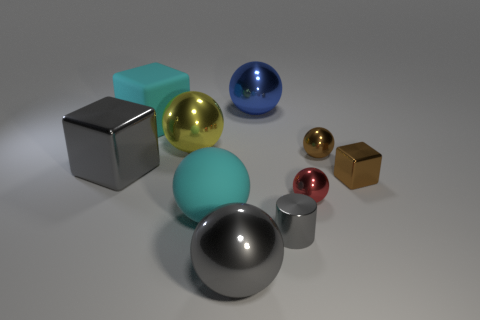Subtract all blue spheres. How many spheres are left? 5 Subtract all small metal spheres. How many spheres are left? 4 Subtract 1 balls. How many balls are left? 5 Subtract all cyan cubes. Subtract all cyan spheres. How many cubes are left? 2 Subtract all cubes. How many objects are left? 7 Add 1 small metallic cylinders. How many small metallic cylinders are left? 2 Add 9 shiny cylinders. How many shiny cylinders exist? 10 Subtract 0 green cylinders. How many objects are left? 10 Subtract all brown shiny blocks. Subtract all green objects. How many objects are left? 9 